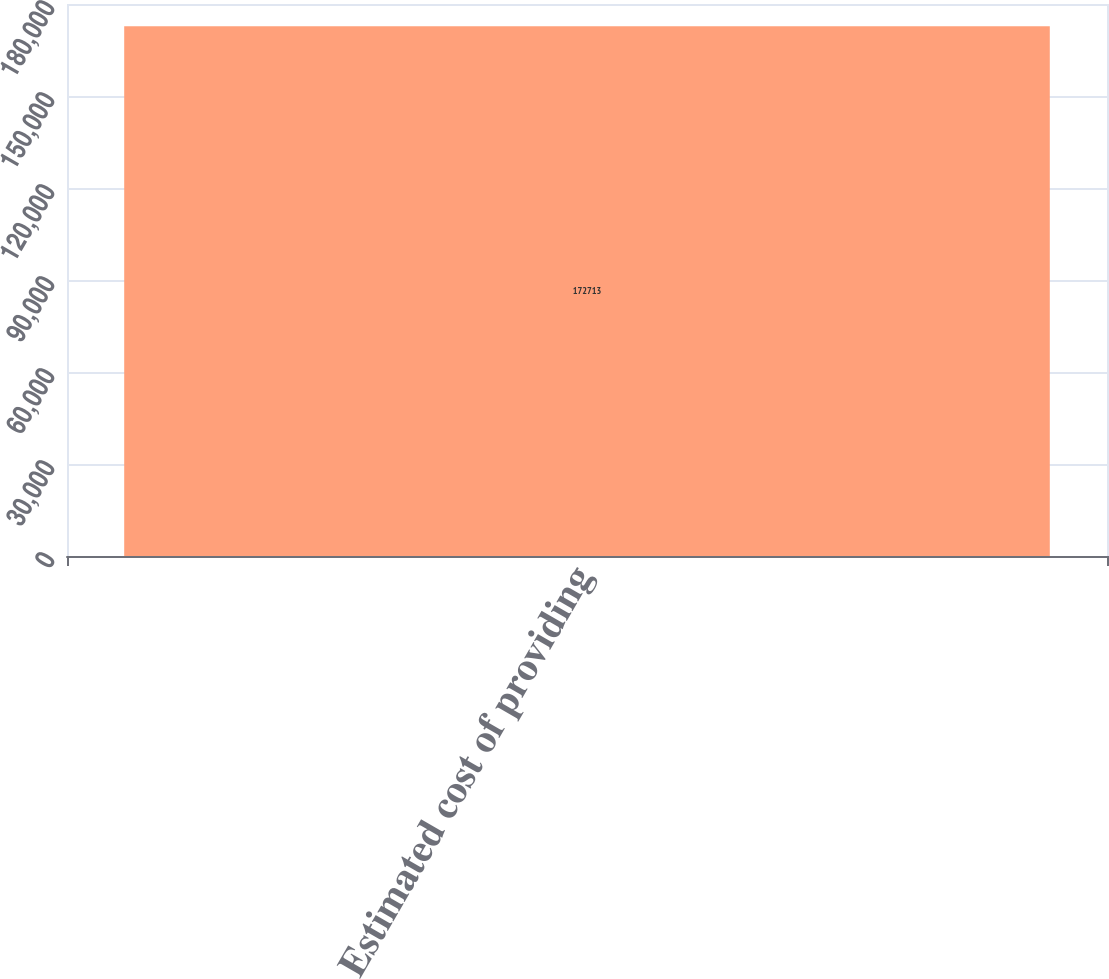<chart> <loc_0><loc_0><loc_500><loc_500><bar_chart><fcel>Estimated cost of providing<nl><fcel>172713<nl></chart> 